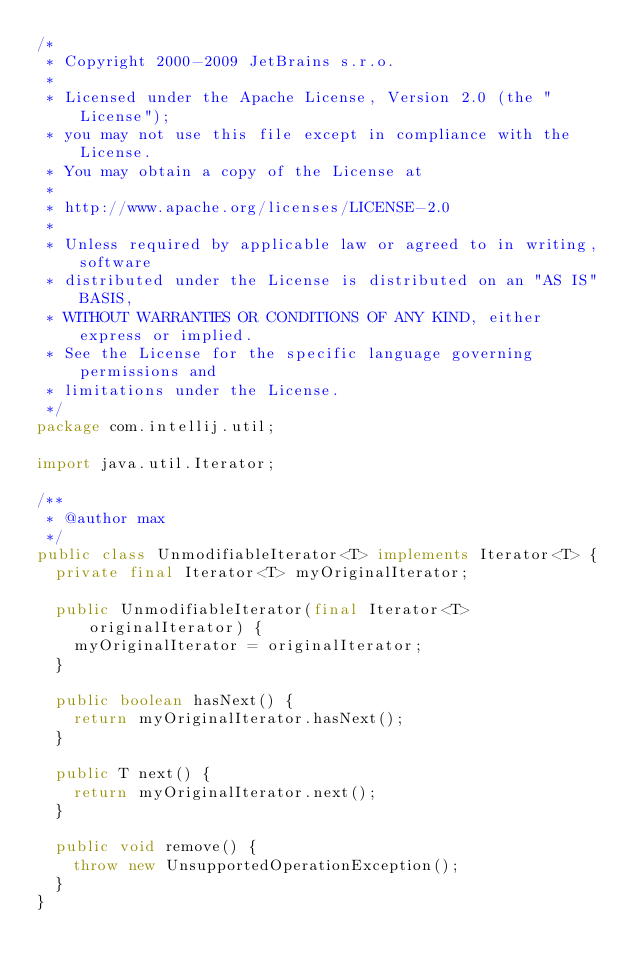<code> <loc_0><loc_0><loc_500><loc_500><_Java_>/*
 * Copyright 2000-2009 JetBrains s.r.o.
 *
 * Licensed under the Apache License, Version 2.0 (the "License");
 * you may not use this file except in compliance with the License.
 * You may obtain a copy of the License at
 *
 * http://www.apache.org/licenses/LICENSE-2.0
 *
 * Unless required by applicable law or agreed to in writing, software
 * distributed under the License is distributed on an "AS IS" BASIS,
 * WITHOUT WARRANTIES OR CONDITIONS OF ANY KIND, either express or implied.
 * See the License for the specific language governing permissions and
 * limitations under the License.
 */
package com.intellij.util;

import java.util.Iterator;

/**
 * @author max
 */
public class UnmodifiableIterator<T> implements Iterator<T> {
  private final Iterator<T> myOriginalIterator;

  public UnmodifiableIterator(final Iterator<T> originalIterator) {
    myOriginalIterator = originalIterator;
  }

  public boolean hasNext() {
    return myOriginalIterator.hasNext();
  }

  public T next() {
    return myOriginalIterator.next();
  }

  public void remove() {
    throw new UnsupportedOperationException();
  }
}
</code> 